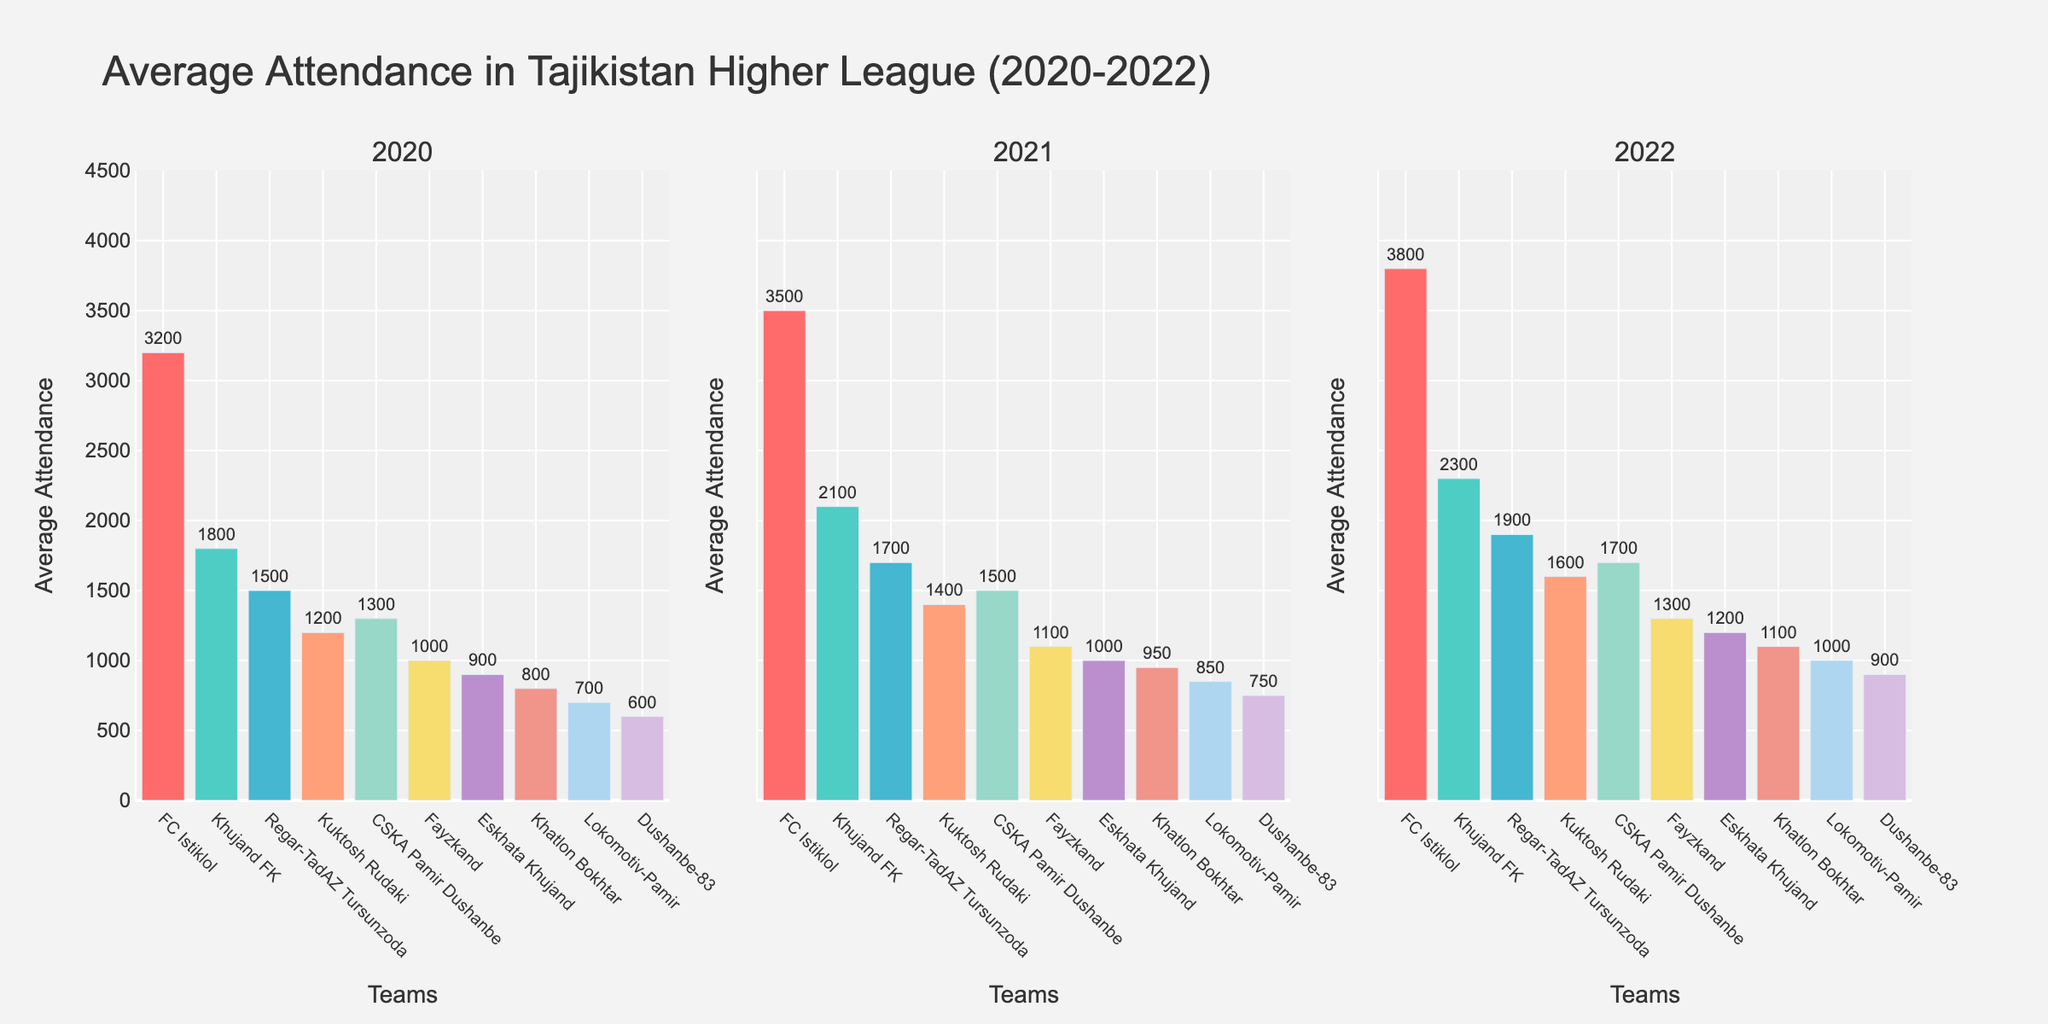What is the title of the plot? The title is displayed at the top of the plot and provides an overall description of the data shown in the figure.
Answer: Average Attendance in Tajikistan Higher League (2020-2022) Which team had the highest average attendance in 2022? Look at the bar heights for the year 2022 subplot, and FC Istiklol had the highest bar.
Answer: FC Istiklol Which teams had average attendance figures below 1000 in 2020? Check the bars for the year 2020 in the subplot; Dushanbe-83, Lokomotiv-Pamir, Khatlon Bokhtar, and Eskhata Khujand have bars below the 1000 mark on the y-axis.
Answer: Dushanbe-83, Lokomotiv-Pamir, Khatlon Bokhtar, Eskhata Khujand By how much did the average attendance of Khujand FK increase from 2020 to 2022? Find the values for Khujand FK in the years 2020 (1800) and 2022 (2300). Subtract the value for 2020 from the value for 2022. 2300 - 1800 = 500.
Answer: 500 Compare the average attendance of Fayzkand in 2021 to that of CSKA Pamir Dushanbe in 2022. Which one is greater? Fayzkand had an average attendance of 1100 in 2021, while CSKA Pamir Dushanbe had an average attendance of 1700 in 2022. 1700 is greater than 1100.
Answer: CSKA Pamir Dushanbe in 2022 What is the average attendance for FC Istiklol across the 3 years? Sum the average attendances of FC Istiklol for the years 2020 (3200), 2021 (3500), and 2022 (3800). Then divide by 3. (3200 + 3500 + 3800) / 3 = 3500.
Answer: 3500 Which year saw the highest average attendance for Kuktosh Rudaki? Compare the bar heights for Kuktosh Rudaki across the three subplots. The tallest bar corresponds to the year 2022.
Answer: 2022 How many teams had an increase in average attendance from 2020 to 2021? Compare the bars for each team between the 2020 and 2021 subplots. All teams have increased attendance from 2020 to 2021.
Answer: 10 teams What can you infer about the overall trend in average attendance from 2020 to 2022? Look at the bars across the three subplots for each team. The general trend is an increase in average attendance from 2020 to 2022.
Answer: Increasing trend 